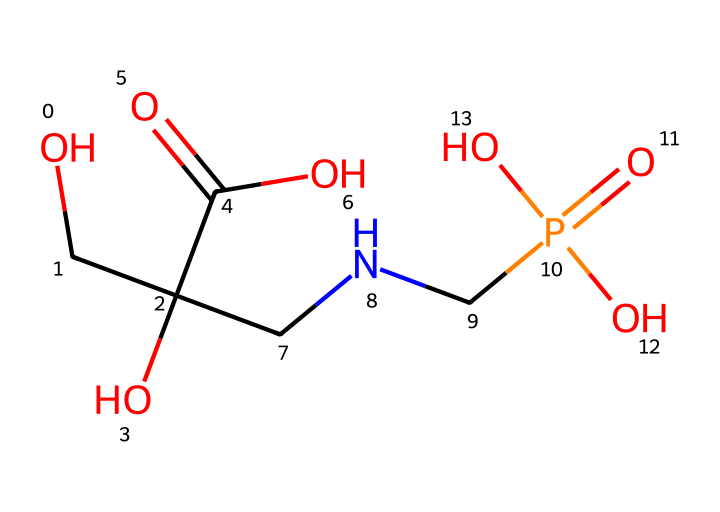what is the total number of carbon atoms in glyphosate? Examining the SMILES representation, we can identify the carbon atoms present. The structure indicates three carbon atoms connected to different functional groups.
Answer: 3 how many nitrogen atoms are present in this chemical? By analyzing the SMILES, we can see there are two nitrogen atoms connected in the structure.
Answer: 2 what functional groups can be identified in glyphosate? The SMILES indicates the presence of a carboxylic acid group (-COOH), a hydroxyl group (-OH), and an amine group (-NH).
Answer: carboxylic acid, hydroxyl, amine what is the molecular weight of glyphosate? To calculate the molecular weight, we sum the atomic weights of all atoms in the molecule, which consists of 3 carbon, 8 hydrogen, 2 nitrogen, and 4 oxygen atoms. This gives a molecular weight of approximately 169.07 g/mol.
Answer: 169.07 g/mol how does glyphosate act as a herbicide? Glyphosate inhibits specific pathways in plants that are essential for growth, particularly by blocking the shikimic acid pathway. This pathway is not present in animals, making glyphosate effective as a herbicide while minimizing harm to non-target species.
Answer: inhibits shikimic acid pathway what type of herbicide is glyphosate classified as? Glyphosate is classified as a systemic herbicide, which means it can be absorbed by the plant and translocated throughout its tissues.
Answer: systemic what is the significance of the phosphonate group in glyphosate? The phosphonate group contributes to glyphosate's efficacy as a herbicide by acting as a phosphate analog, disrupting normal metabolic processes in the target plant.
Answer: herbicidal efficacy 